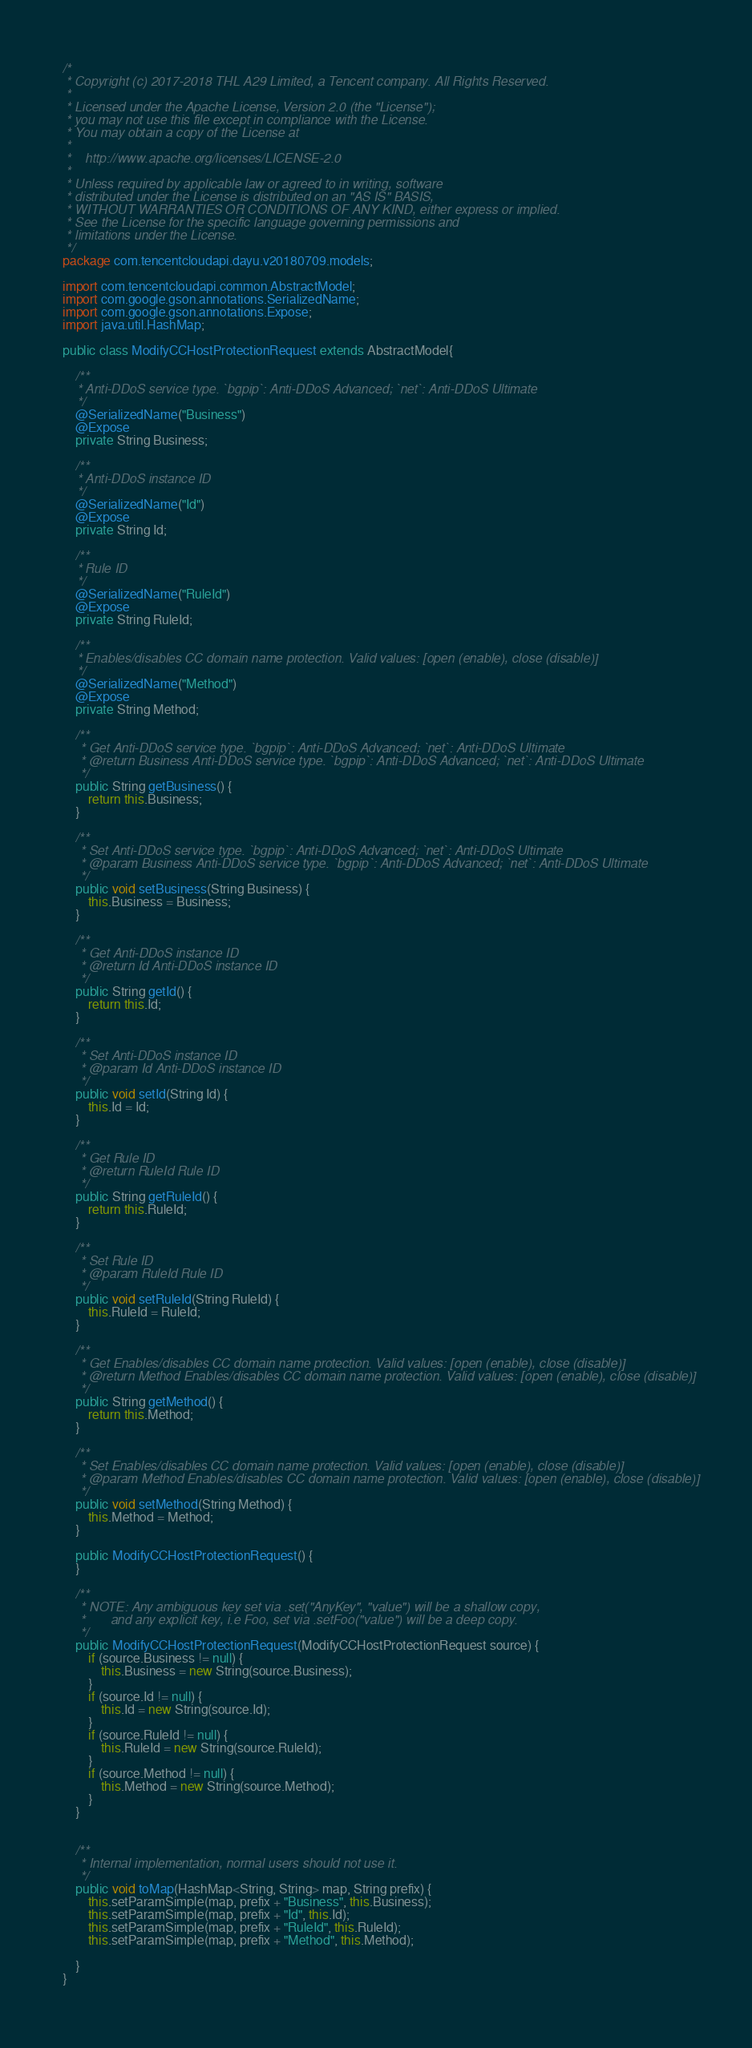Convert code to text. <code><loc_0><loc_0><loc_500><loc_500><_Java_>/*
 * Copyright (c) 2017-2018 THL A29 Limited, a Tencent company. All Rights Reserved.
 *
 * Licensed under the Apache License, Version 2.0 (the "License");
 * you may not use this file except in compliance with the License.
 * You may obtain a copy of the License at
 *
 *    http://www.apache.org/licenses/LICENSE-2.0
 *
 * Unless required by applicable law or agreed to in writing, software
 * distributed under the License is distributed on an "AS IS" BASIS,
 * WITHOUT WARRANTIES OR CONDITIONS OF ANY KIND, either express or implied.
 * See the License for the specific language governing permissions and
 * limitations under the License.
 */
package com.tencentcloudapi.dayu.v20180709.models;

import com.tencentcloudapi.common.AbstractModel;
import com.google.gson.annotations.SerializedName;
import com.google.gson.annotations.Expose;
import java.util.HashMap;

public class ModifyCCHostProtectionRequest extends AbstractModel{

    /**
    * Anti-DDoS service type. `bgpip`: Anti-DDoS Advanced; `net`: Anti-DDoS Ultimate
    */
    @SerializedName("Business")
    @Expose
    private String Business;

    /**
    * Anti-DDoS instance ID
    */
    @SerializedName("Id")
    @Expose
    private String Id;

    /**
    * Rule ID
    */
    @SerializedName("RuleId")
    @Expose
    private String RuleId;

    /**
    * Enables/disables CC domain name protection. Valid values: [open (enable), close (disable)]
    */
    @SerializedName("Method")
    @Expose
    private String Method;

    /**
     * Get Anti-DDoS service type. `bgpip`: Anti-DDoS Advanced; `net`: Anti-DDoS Ultimate 
     * @return Business Anti-DDoS service type. `bgpip`: Anti-DDoS Advanced; `net`: Anti-DDoS Ultimate
     */
    public String getBusiness() {
        return this.Business;
    }

    /**
     * Set Anti-DDoS service type. `bgpip`: Anti-DDoS Advanced; `net`: Anti-DDoS Ultimate
     * @param Business Anti-DDoS service type. `bgpip`: Anti-DDoS Advanced; `net`: Anti-DDoS Ultimate
     */
    public void setBusiness(String Business) {
        this.Business = Business;
    }

    /**
     * Get Anti-DDoS instance ID 
     * @return Id Anti-DDoS instance ID
     */
    public String getId() {
        return this.Id;
    }

    /**
     * Set Anti-DDoS instance ID
     * @param Id Anti-DDoS instance ID
     */
    public void setId(String Id) {
        this.Id = Id;
    }

    /**
     * Get Rule ID 
     * @return RuleId Rule ID
     */
    public String getRuleId() {
        return this.RuleId;
    }

    /**
     * Set Rule ID
     * @param RuleId Rule ID
     */
    public void setRuleId(String RuleId) {
        this.RuleId = RuleId;
    }

    /**
     * Get Enables/disables CC domain name protection. Valid values: [open (enable), close (disable)] 
     * @return Method Enables/disables CC domain name protection. Valid values: [open (enable), close (disable)]
     */
    public String getMethod() {
        return this.Method;
    }

    /**
     * Set Enables/disables CC domain name protection. Valid values: [open (enable), close (disable)]
     * @param Method Enables/disables CC domain name protection. Valid values: [open (enable), close (disable)]
     */
    public void setMethod(String Method) {
        this.Method = Method;
    }

    public ModifyCCHostProtectionRequest() {
    }

    /**
     * NOTE: Any ambiguous key set via .set("AnyKey", "value") will be a shallow copy,
     *       and any explicit key, i.e Foo, set via .setFoo("value") will be a deep copy.
     */
    public ModifyCCHostProtectionRequest(ModifyCCHostProtectionRequest source) {
        if (source.Business != null) {
            this.Business = new String(source.Business);
        }
        if (source.Id != null) {
            this.Id = new String(source.Id);
        }
        if (source.RuleId != null) {
            this.RuleId = new String(source.RuleId);
        }
        if (source.Method != null) {
            this.Method = new String(source.Method);
        }
    }


    /**
     * Internal implementation, normal users should not use it.
     */
    public void toMap(HashMap<String, String> map, String prefix) {
        this.setParamSimple(map, prefix + "Business", this.Business);
        this.setParamSimple(map, prefix + "Id", this.Id);
        this.setParamSimple(map, prefix + "RuleId", this.RuleId);
        this.setParamSimple(map, prefix + "Method", this.Method);

    }
}

</code> 